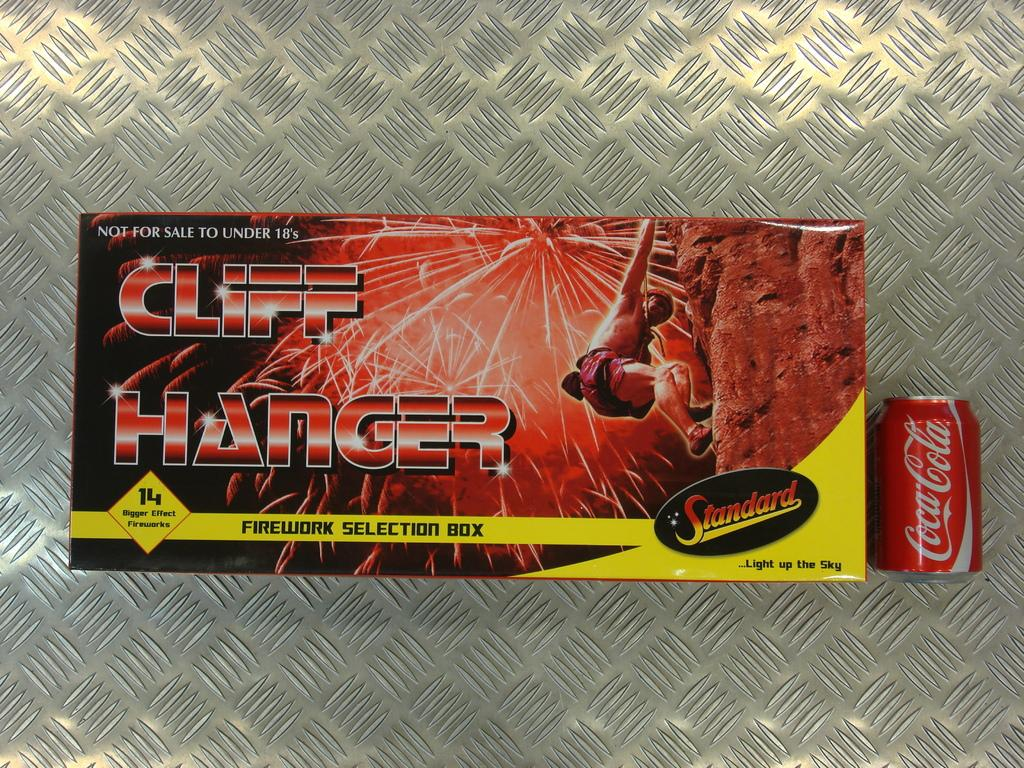What object is present in the image that is not a coke tin? There is a box in the image. What is written on the coke tin in the image? There is text on the coke tin. What can be found on the box besides text? There is a picture of a person on the box. What is the surface at the bottom of the image made of? The bottom of the image appears to be a metal floor. Where is the park located in the image? There is no park present in the image. 